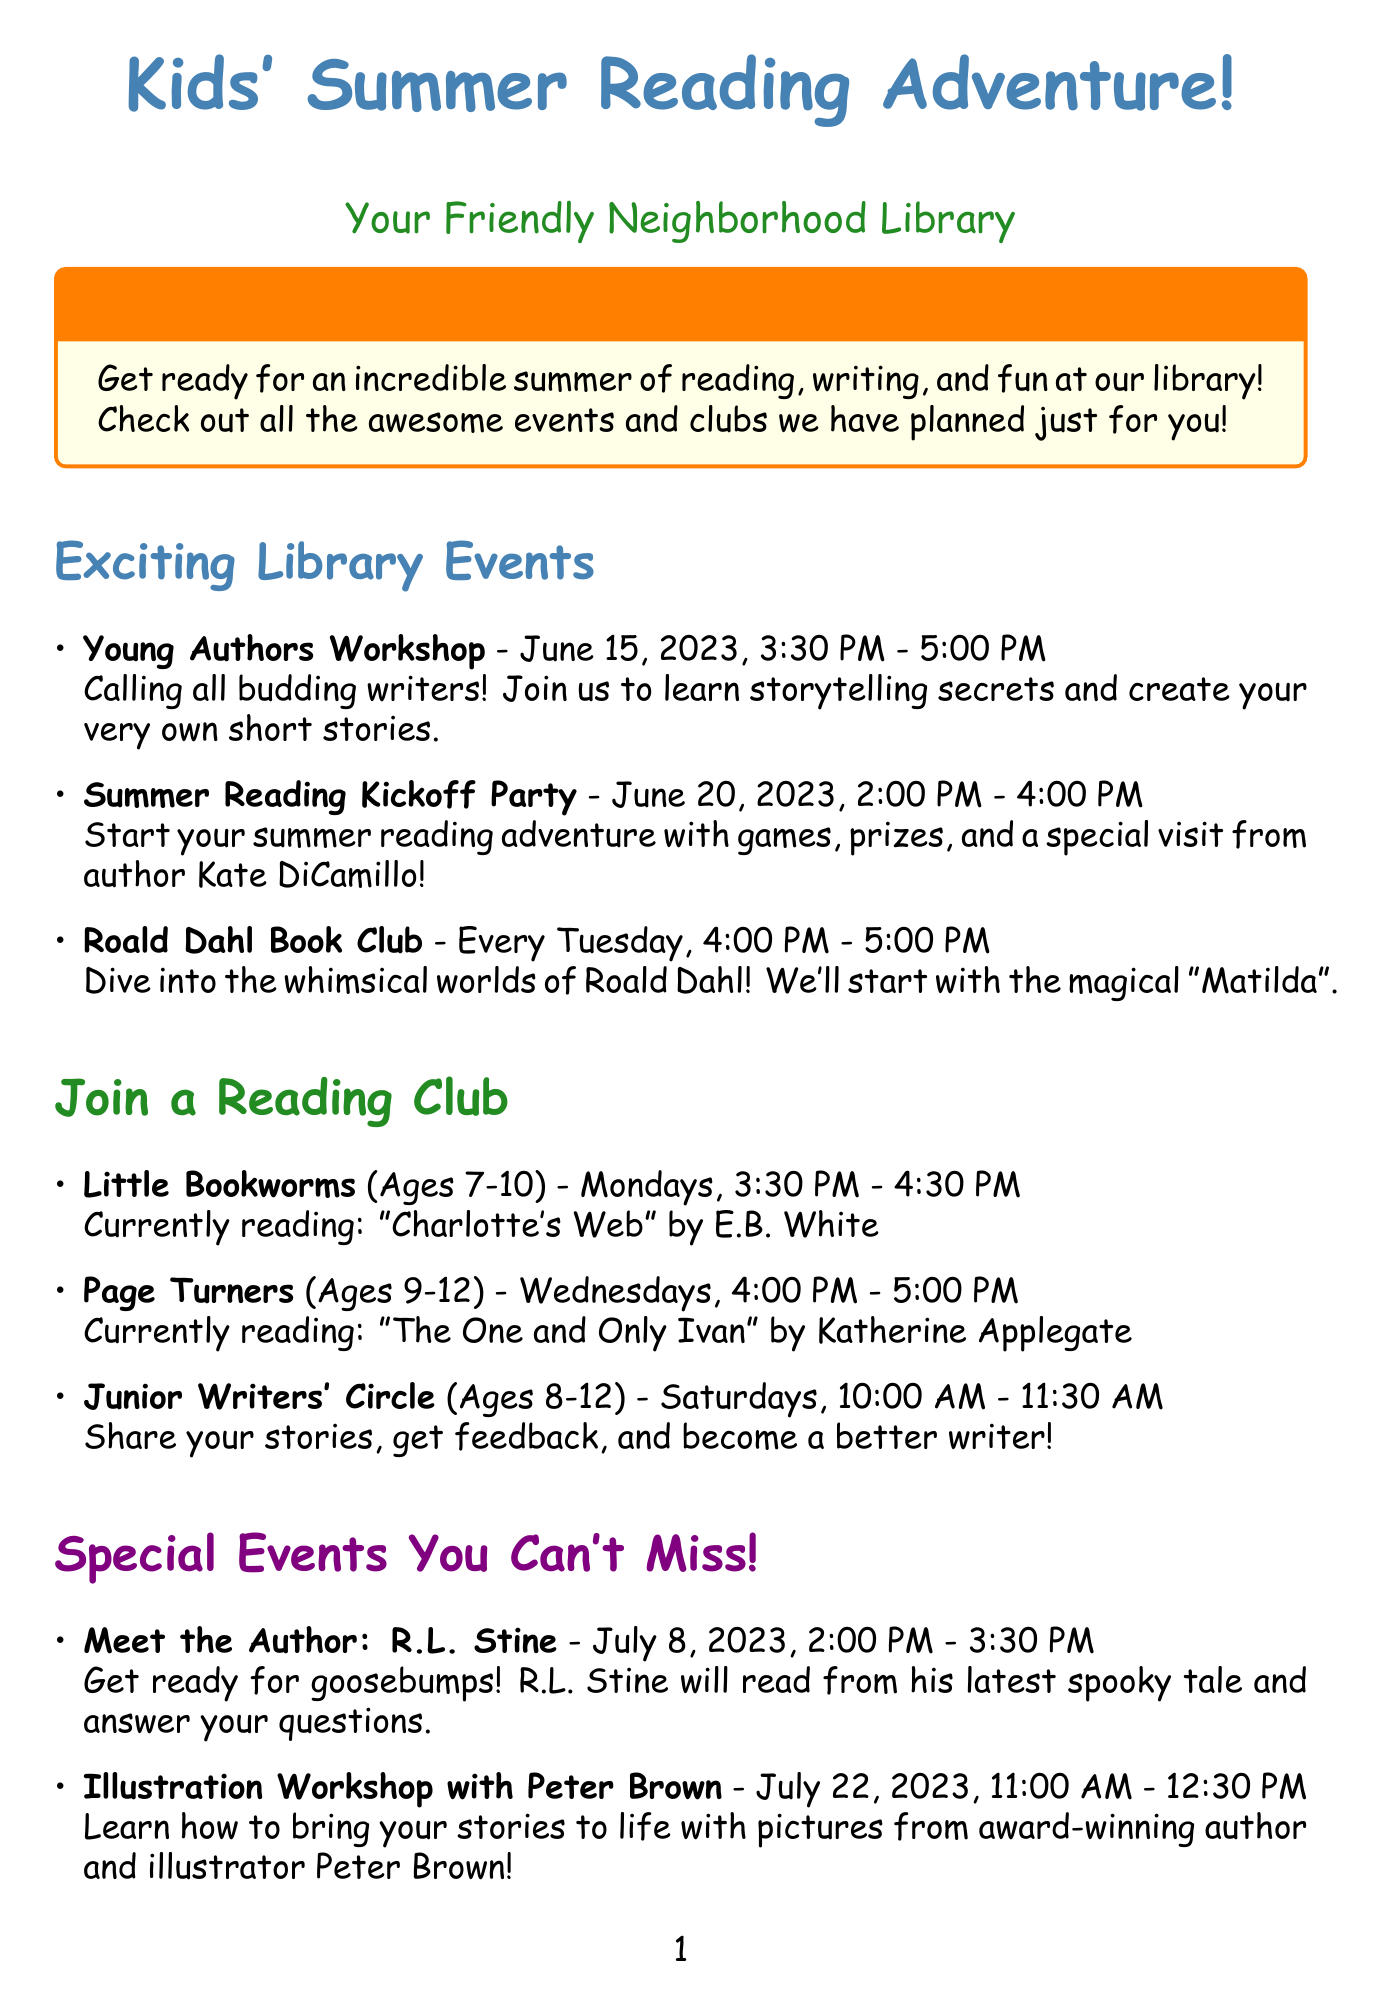What is the name of the workshop for young authors? The name of the workshop specifically designed for young authors is mentioned in the document.
Answer: Young Authors Workshop When does the Summer Reading Kickoff Party take place? The specific date for the Summer Reading Kickoff Party is provided in the event list.
Answer: June 20, 2023 What age group is the Little Bookworms reading club for? The document provides clear information about the targeted age group for the Little Bookworms club.
Answer: 7-10 years Who is the author visiting on July 8, 2023? The document specifies the name of the author who will be visiting the library on that date.
Answer: R.L. Stine What book are the Page Turners currently reading? The current book for the Page Turners club is directly listed in the document.
Answer: The One and Only Ivan What is the duration of the Summer Reading Challenge? The document outlines the start and end dates for the Summer Reading Challenge, which represents its duration.
Answer: June 20 - August 15, 2023 What special activity will Peter Brown be conducting? The document describes the unique event led by Peter Brown.
Answer: Illustration Workshop How often does the Roald Dahl Book Club meet? The frequency of the Roald Dahl Book Club meetings is specified in the document.
Answer: Every Tuesday 